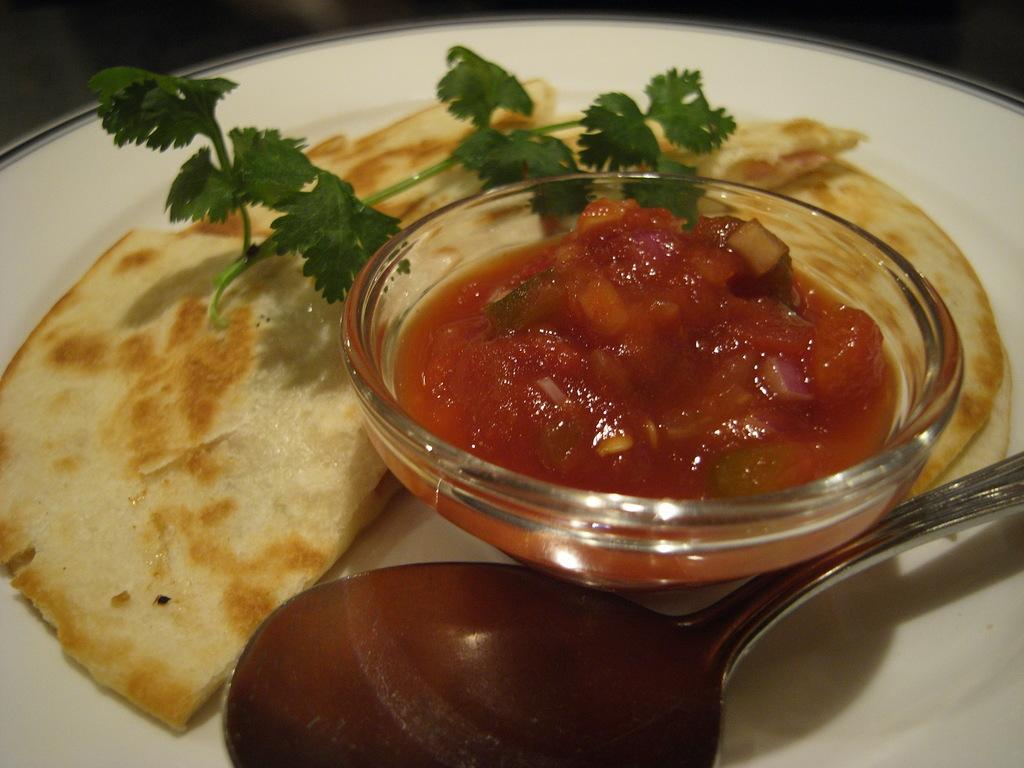What is present on the plate in the image? There is no information about the plate's contents in the provided facts. What type of food can be seen in the bowl? There is a bowl with food in the image, but the specific type of food is not mentioned. What utensil is visible in the image? There is a spoon in the image. What is the texture of the fight happening in the image? There is no fight present in the image, so the texture cannot be determined. 